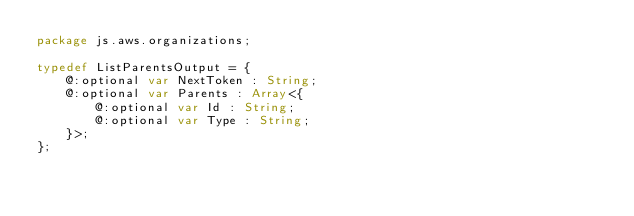<code> <loc_0><loc_0><loc_500><loc_500><_Haxe_>package js.aws.organizations;

typedef ListParentsOutput = {
    @:optional var NextToken : String;
    @:optional var Parents : Array<{
        @:optional var Id : String;
        @:optional var Type : String;
    }>;
};
</code> 